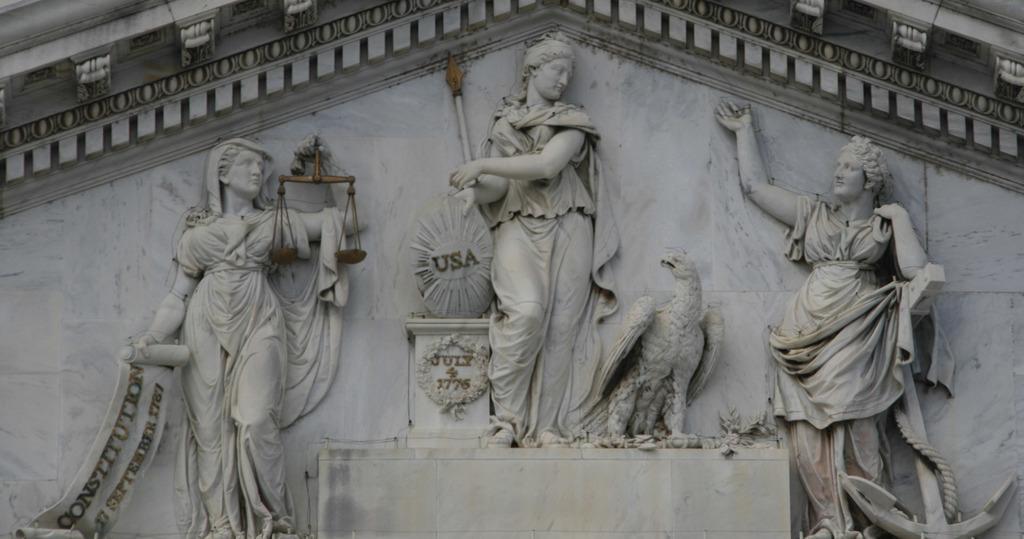How would you summarize this image in a sentence or two? In this picture I can see there are few sculptures of women and a eagle on the wall. 